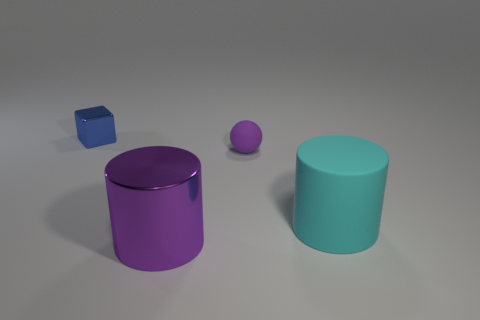Add 4 large metal objects. How many objects exist? 8 Subtract all cubes. How many objects are left? 3 Subtract all cyan cylinders. How many cylinders are left? 1 Subtract 1 cylinders. How many cylinders are left? 1 Subtract all brown cylinders. Subtract all purple spheres. How many cylinders are left? 2 Subtract all yellow balls. How many cyan cylinders are left? 1 Subtract all yellow matte cubes. Subtract all big objects. How many objects are left? 2 Add 2 big cylinders. How many big cylinders are left? 4 Add 2 tiny blue rubber blocks. How many tiny blue rubber blocks exist? 2 Subtract 0 blue spheres. How many objects are left? 4 